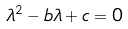<formula> <loc_0><loc_0><loc_500><loc_500>\lambda ^ { 2 } - b \lambda + c = 0</formula> 